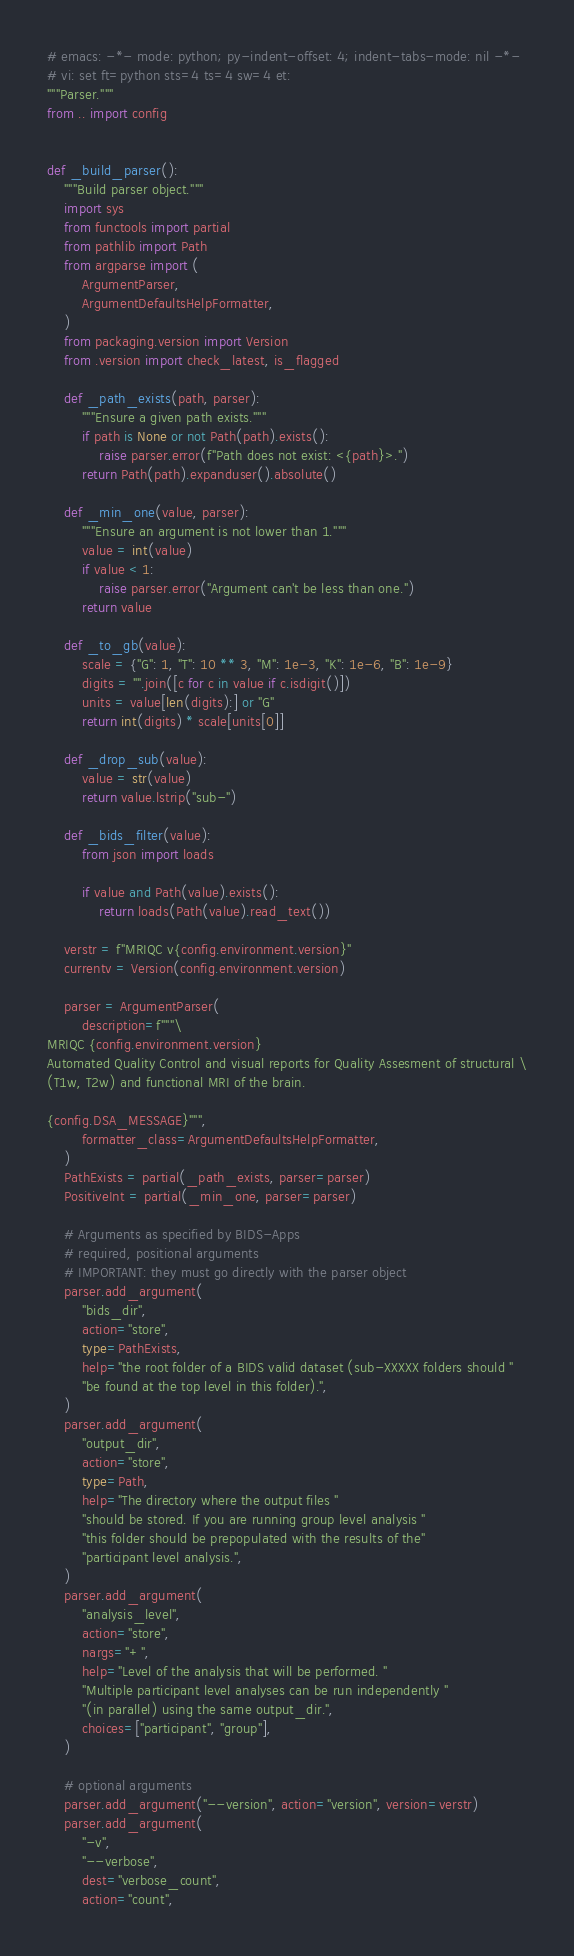Convert code to text. <code><loc_0><loc_0><loc_500><loc_500><_Python_># emacs: -*- mode: python; py-indent-offset: 4; indent-tabs-mode: nil -*-
# vi: set ft=python sts=4 ts=4 sw=4 et:
"""Parser."""
from .. import config


def _build_parser():
    """Build parser object."""
    import sys
    from functools import partial
    from pathlib import Path
    from argparse import (
        ArgumentParser,
        ArgumentDefaultsHelpFormatter,
    )
    from packaging.version import Version
    from .version import check_latest, is_flagged

    def _path_exists(path, parser):
        """Ensure a given path exists."""
        if path is None or not Path(path).exists():
            raise parser.error(f"Path does not exist: <{path}>.")
        return Path(path).expanduser().absolute()

    def _min_one(value, parser):
        """Ensure an argument is not lower than 1."""
        value = int(value)
        if value < 1:
            raise parser.error("Argument can't be less than one.")
        return value

    def _to_gb(value):
        scale = {"G": 1, "T": 10 ** 3, "M": 1e-3, "K": 1e-6, "B": 1e-9}
        digits = "".join([c for c in value if c.isdigit()])
        units = value[len(digits):] or "G"
        return int(digits) * scale[units[0]]

    def _drop_sub(value):
        value = str(value)
        return value.lstrip("sub-")

    def _bids_filter(value):
        from json import loads

        if value and Path(value).exists():
            return loads(Path(value).read_text())

    verstr = f"MRIQC v{config.environment.version}"
    currentv = Version(config.environment.version)

    parser = ArgumentParser(
        description=f"""\
MRIQC {config.environment.version}
Automated Quality Control and visual reports for Quality Assesment of structural \
(T1w, T2w) and functional MRI of the brain.

{config.DSA_MESSAGE}""",
        formatter_class=ArgumentDefaultsHelpFormatter,
    )
    PathExists = partial(_path_exists, parser=parser)
    PositiveInt = partial(_min_one, parser=parser)

    # Arguments as specified by BIDS-Apps
    # required, positional arguments
    # IMPORTANT: they must go directly with the parser object
    parser.add_argument(
        "bids_dir",
        action="store",
        type=PathExists,
        help="the root folder of a BIDS valid dataset (sub-XXXXX folders should "
        "be found at the top level in this folder).",
    )
    parser.add_argument(
        "output_dir",
        action="store",
        type=Path,
        help="The directory where the output files "
        "should be stored. If you are running group level analysis "
        "this folder should be prepopulated with the results of the"
        "participant level analysis.",
    )
    parser.add_argument(
        "analysis_level",
        action="store",
        nargs="+",
        help="Level of the analysis that will be performed. "
        "Multiple participant level analyses can be run independently "
        "(in parallel) using the same output_dir.",
        choices=["participant", "group"],
    )

    # optional arguments
    parser.add_argument("--version", action="version", version=verstr)
    parser.add_argument(
        "-v",
        "--verbose",
        dest="verbose_count",
        action="count",</code> 